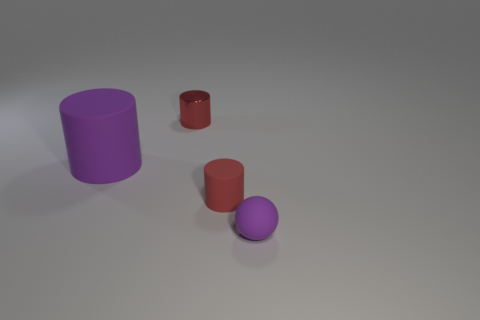Is the purple matte ball the same size as the red metallic cylinder?
Your answer should be very brief. Yes. There is a tiny matte object that is the same color as the small shiny object; what is its shape?
Provide a succinct answer. Cylinder. There is a purple cylinder; is it the same size as the red cylinder in front of the large purple matte cylinder?
Make the answer very short. No. What color is the cylinder that is both on the left side of the small red matte object and in front of the small metallic object?
Provide a short and direct response. Purple. Is the number of purple matte things that are to the right of the tiny red matte cylinder greater than the number of metallic cylinders that are behind the small metallic thing?
Offer a very short reply. Yes. What size is the sphere that is the same material as the purple cylinder?
Ensure brevity in your answer.  Small. There is a object behind the big cylinder; how many purple rubber cylinders are to the right of it?
Give a very brief answer. 0. Is there a purple thing that has the same shape as the red rubber thing?
Offer a very short reply. Yes. What is the color of the matte cylinder to the right of the purple rubber object on the left side of the metal thing?
Keep it short and to the point. Red. Are there more rubber cubes than balls?
Provide a short and direct response. No. 